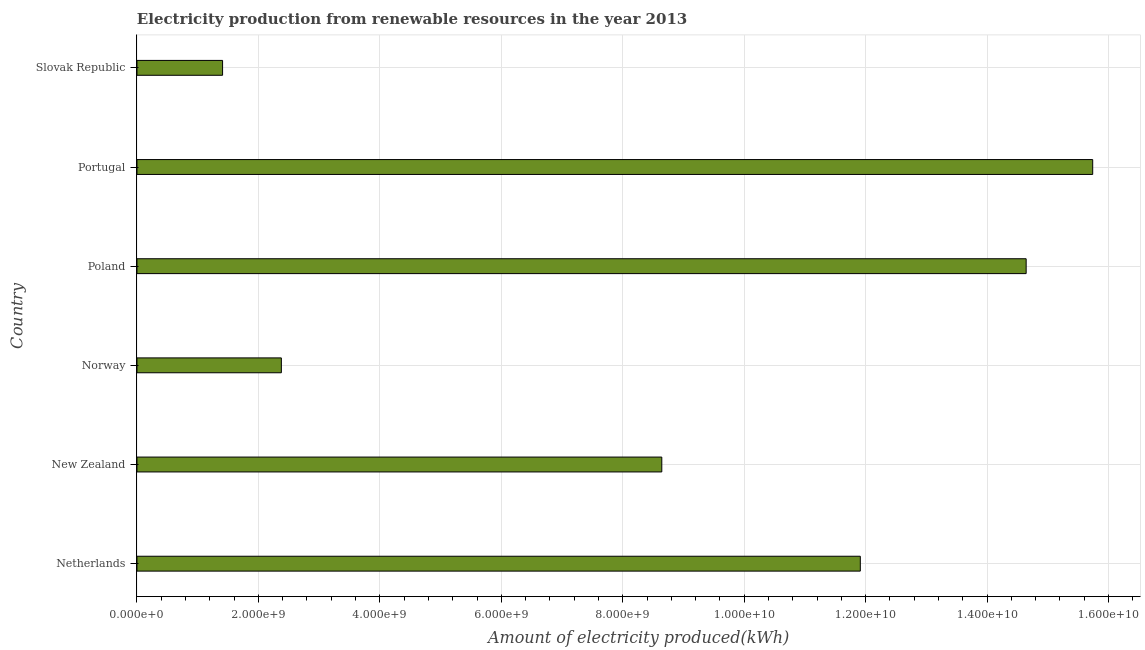Does the graph contain grids?
Your answer should be very brief. Yes. What is the title of the graph?
Provide a succinct answer. Electricity production from renewable resources in the year 2013. What is the label or title of the X-axis?
Your answer should be compact. Amount of electricity produced(kWh). What is the label or title of the Y-axis?
Offer a terse response. Country. What is the amount of electricity produced in New Zealand?
Your answer should be compact. 8.64e+09. Across all countries, what is the maximum amount of electricity produced?
Make the answer very short. 1.57e+1. Across all countries, what is the minimum amount of electricity produced?
Offer a terse response. 1.41e+09. In which country was the amount of electricity produced maximum?
Provide a succinct answer. Portugal. In which country was the amount of electricity produced minimum?
Your answer should be very brief. Slovak Republic. What is the sum of the amount of electricity produced?
Ensure brevity in your answer.  5.47e+1. What is the difference between the amount of electricity produced in Norway and Poland?
Keep it short and to the point. -1.23e+1. What is the average amount of electricity produced per country?
Provide a short and direct response. 9.12e+09. What is the median amount of electricity produced?
Provide a succinct answer. 1.03e+1. What is the ratio of the amount of electricity produced in Netherlands to that in Poland?
Provide a short and direct response. 0.81. Is the difference between the amount of electricity produced in Netherlands and Poland greater than the difference between any two countries?
Keep it short and to the point. No. What is the difference between the highest and the second highest amount of electricity produced?
Provide a succinct answer. 1.10e+09. What is the difference between the highest and the lowest amount of electricity produced?
Your answer should be very brief. 1.43e+1. In how many countries, is the amount of electricity produced greater than the average amount of electricity produced taken over all countries?
Your answer should be compact. 3. How many countries are there in the graph?
Your answer should be compact. 6. What is the difference between two consecutive major ticks on the X-axis?
Your answer should be compact. 2.00e+09. Are the values on the major ticks of X-axis written in scientific E-notation?
Provide a succinct answer. Yes. What is the Amount of electricity produced(kWh) of Netherlands?
Make the answer very short. 1.19e+1. What is the Amount of electricity produced(kWh) of New Zealand?
Offer a very short reply. 8.64e+09. What is the Amount of electricity produced(kWh) of Norway?
Provide a short and direct response. 2.38e+09. What is the Amount of electricity produced(kWh) in Poland?
Give a very brief answer. 1.46e+1. What is the Amount of electricity produced(kWh) in Portugal?
Provide a short and direct response. 1.57e+1. What is the Amount of electricity produced(kWh) in Slovak Republic?
Your answer should be compact. 1.41e+09. What is the difference between the Amount of electricity produced(kWh) in Netherlands and New Zealand?
Offer a very short reply. 3.27e+09. What is the difference between the Amount of electricity produced(kWh) in Netherlands and Norway?
Provide a short and direct response. 9.53e+09. What is the difference between the Amount of electricity produced(kWh) in Netherlands and Poland?
Your answer should be compact. -2.73e+09. What is the difference between the Amount of electricity produced(kWh) in Netherlands and Portugal?
Offer a terse response. -3.83e+09. What is the difference between the Amount of electricity produced(kWh) in Netherlands and Slovak Republic?
Your answer should be very brief. 1.05e+1. What is the difference between the Amount of electricity produced(kWh) in New Zealand and Norway?
Offer a terse response. 6.26e+09. What is the difference between the Amount of electricity produced(kWh) in New Zealand and Poland?
Offer a very short reply. -6.00e+09. What is the difference between the Amount of electricity produced(kWh) in New Zealand and Portugal?
Your answer should be very brief. -7.10e+09. What is the difference between the Amount of electricity produced(kWh) in New Zealand and Slovak Republic?
Keep it short and to the point. 7.23e+09. What is the difference between the Amount of electricity produced(kWh) in Norway and Poland?
Provide a succinct answer. -1.23e+1. What is the difference between the Amount of electricity produced(kWh) in Norway and Portugal?
Offer a very short reply. -1.34e+1. What is the difference between the Amount of electricity produced(kWh) in Norway and Slovak Republic?
Your answer should be very brief. 9.68e+08. What is the difference between the Amount of electricity produced(kWh) in Poland and Portugal?
Your answer should be compact. -1.10e+09. What is the difference between the Amount of electricity produced(kWh) in Poland and Slovak Republic?
Your answer should be compact. 1.32e+1. What is the difference between the Amount of electricity produced(kWh) in Portugal and Slovak Republic?
Ensure brevity in your answer.  1.43e+1. What is the ratio of the Amount of electricity produced(kWh) in Netherlands to that in New Zealand?
Offer a terse response. 1.38. What is the ratio of the Amount of electricity produced(kWh) in Netherlands to that in Norway?
Keep it short and to the point. 5.01. What is the ratio of the Amount of electricity produced(kWh) in Netherlands to that in Poland?
Give a very brief answer. 0.81. What is the ratio of the Amount of electricity produced(kWh) in Netherlands to that in Portugal?
Keep it short and to the point. 0.76. What is the ratio of the Amount of electricity produced(kWh) in Netherlands to that in Slovak Republic?
Provide a short and direct response. 8.45. What is the ratio of the Amount of electricity produced(kWh) in New Zealand to that in Norway?
Provide a succinct answer. 3.63. What is the ratio of the Amount of electricity produced(kWh) in New Zealand to that in Poland?
Make the answer very short. 0.59. What is the ratio of the Amount of electricity produced(kWh) in New Zealand to that in Portugal?
Your response must be concise. 0.55. What is the ratio of the Amount of electricity produced(kWh) in New Zealand to that in Slovak Republic?
Give a very brief answer. 6.13. What is the ratio of the Amount of electricity produced(kWh) in Norway to that in Poland?
Make the answer very short. 0.16. What is the ratio of the Amount of electricity produced(kWh) in Norway to that in Portugal?
Make the answer very short. 0.15. What is the ratio of the Amount of electricity produced(kWh) in Norway to that in Slovak Republic?
Your response must be concise. 1.69. What is the ratio of the Amount of electricity produced(kWh) in Poland to that in Portugal?
Provide a short and direct response. 0.93. What is the ratio of the Amount of electricity produced(kWh) in Poland to that in Slovak Republic?
Your answer should be compact. 10.38. What is the ratio of the Amount of electricity produced(kWh) in Portugal to that in Slovak Republic?
Make the answer very short. 11.16. 